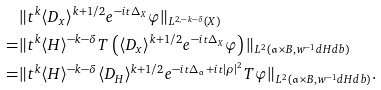<formula> <loc_0><loc_0><loc_500><loc_500>& \| t ^ { k } \langle D _ { x } \rangle ^ { k + 1 / 2 } e ^ { - i t \Delta _ { X } } \varphi \| _ { L ^ { 2 , - k - \delta } ( X ) } \\ = & \| t ^ { k } \langle H \rangle ^ { - k - \delta } T \left ( \langle D _ { x } \rangle ^ { k + 1 / 2 } e ^ { - i t \Delta _ { X } } \varphi \right ) \| _ { L ^ { 2 } ( \mathfrak { a } \times B , w ^ { - 1 } d H d b ) } \\ = & \| t ^ { k } \langle H \rangle ^ { - k - \delta } \langle D _ { H } \rangle ^ { k + 1 / 2 } e ^ { - i t \Delta _ { \mathfrak { a } } + i t | \rho | ^ { 2 } } T \varphi \| _ { L ^ { 2 } ( \mathfrak { a } \times B , w ^ { - 1 } d H d b ) } .</formula> 